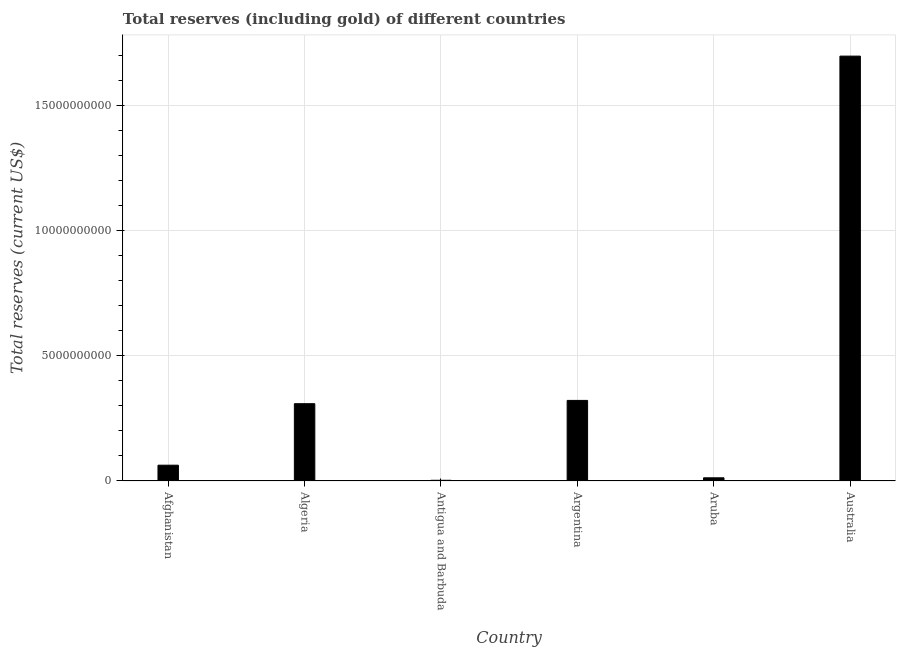Does the graph contain any zero values?
Your response must be concise. No. What is the title of the graph?
Provide a succinct answer. Total reserves (including gold) of different countries. What is the label or title of the Y-axis?
Make the answer very short. Total reserves (current US$). What is the total reserves (including gold) in Afghanistan?
Keep it short and to the point. 6.31e+08. Across all countries, what is the maximum total reserves (including gold)?
Give a very brief answer. 1.70e+1. Across all countries, what is the minimum total reserves (including gold)?
Provide a succinct answer. 2.81e+07. In which country was the total reserves (including gold) minimum?
Give a very brief answer. Antigua and Barbuda. What is the sum of the total reserves (including gold)?
Make the answer very short. 2.40e+1. What is the difference between the total reserves (including gold) in Afghanistan and Australia?
Your answer should be very brief. -1.63e+1. What is the average total reserves (including gold) per country?
Your response must be concise. 4.01e+09. What is the median total reserves (including gold)?
Offer a terse response. 1.86e+09. In how many countries, is the total reserves (including gold) greater than 2000000000 US$?
Provide a short and direct response. 3. What is the ratio of the total reserves (including gold) in Afghanistan to that in Australia?
Ensure brevity in your answer.  0.04. What is the difference between the highest and the second highest total reserves (including gold)?
Your response must be concise. 1.37e+1. Is the sum of the total reserves (including gold) in Antigua and Barbuda and Argentina greater than the maximum total reserves (including gold) across all countries?
Your answer should be very brief. No. What is the difference between the highest and the lowest total reserves (including gold)?
Keep it short and to the point. 1.69e+1. In how many countries, is the total reserves (including gold) greater than the average total reserves (including gold) taken over all countries?
Make the answer very short. 1. How many bars are there?
Ensure brevity in your answer.  6. What is the difference between two consecutive major ticks on the Y-axis?
Make the answer very short. 5.00e+09. What is the Total reserves (current US$) of Afghanistan?
Keep it short and to the point. 6.31e+08. What is the Total reserves (current US$) of Algeria?
Keep it short and to the point. 3.09e+09. What is the Total reserves (current US$) of Antigua and Barbuda?
Offer a terse response. 2.81e+07. What is the Total reserves (current US$) of Argentina?
Ensure brevity in your answer.  3.22e+09. What is the Total reserves (current US$) of Aruba?
Make the answer very short. 1.27e+08. What is the Total reserves (current US$) in Australia?
Provide a short and direct response. 1.70e+1. What is the difference between the Total reserves (current US$) in Afghanistan and Algeria?
Offer a very short reply. -2.46e+09. What is the difference between the Total reserves (current US$) in Afghanistan and Antigua and Barbuda?
Your answer should be compact. 6.03e+08. What is the difference between the Total reserves (current US$) in Afghanistan and Argentina?
Ensure brevity in your answer.  -2.59e+09. What is the difference between the Total reserves (current US$) in Afghanistan and Aruba?
Offer a very short reply. 5.03e+08. What is the difference between the Total reserves (current US$) in Afghanistan and Australia?
Ensure brevity in your answer.  -1.63e+1. What is the difference between the Total reserves (current US$) in Algeria and Antigua and Barbuda?
Give a very brief answer. 3.06e+09. What is the difference between the Total reserves (current US$) in Algeria and Argentina?
Your answer should be compact. -1.31e+08. What is the difference between the Total reserves (current US$) in Algeria and Aruba?
Your answer should be very brief. 2.96e+09. What is the difference between the Total reserves (current US$) in Algeria and Australia?
Ensure brevity in your answer.  -1.39e+1. What is the difference between the Total reserves (current US$) in Antigua and Barbuda and Argentina?
Offer a terse response. -3.19e+09. What is the difference between the Total reserves (current US$) in Antigua and Barbuda and Aruba?
Provide a succinct answer. -9.91e+07. What is the difference between the Total reserves (current US$) in Antigua and Barbuda and Australia?
Ensure brevity in your answer.  -1.69e+1. What is the difference between the Total reserves (current US$) in Argentina and Aruba?
Offer a very short reply. 3.09e+09. What is the difference between the Total reserves (current US$) in Argentina and Australia?
Keep it short and to the point. -1.37e+1. What is the difference between the Total reserves (current US$) in Aruba and Australia?
Provide a short and direct response. -1.68e+1. What is the ratio of the Total reserves (current US$) in Afghanistan to that in Algeria?
Your answer should be very brief. 0.2. What is the ratio of the Total reserves (current US$) in Afghanistan to that in Antigua and Barbuda?
Provide a succinct answer. 22.47. What is the ratio of the Total reserves (current US$) in Afghanistan to that in Argentina?
Provide a succinct answer. 0.2. What is the ratio of the Total reserves (current US$) in Afghanistan to that in Aruba?
Offer a very short reply. 4.96. What is the ratio of the Total reserves (current US$) in Afghanistan to that in Australia?
Make the answer very short. 0.04. What is the ratio of the Total reserves (current US$) in Algeria to that in Antigua and Barbuda?
Ensure brevity in your answer.  109.93. What is the ratio of the Total reserves (current US$) in Algeria to that in Aruba?
Your answer should be compact. 24.26. What is the ratio of the Total reserves (current US$) in Algeria to that in Australia?
Provide a succinct answer. 0.18. What is the ratio of the Total reserves (current US$) in Antigua and Barbuda to that in Argentina?
Your answer should be very brief. 0.01. What is the ratio of the Total reserves (current US$) in Antigua and Barbuda to that in Aruba?
Offer a terse response. 0.22. What is the ratio of the Total reserves (current US$) in Antigua and Barbuda to that in Australia?
Offer a terse response. 0. What is the ratio of the Total reserves (current US$) in Argentina to that in Aruba?
Your response must be concise. 25.3. What is the ratio of the Total reserves (current US$) in Argentina to that in Australia?
Offer a terse response. 0.19. What is the ratio of the Total reserves (current US$) in Aruba to that in Australia?
Ensure brevity in your answer.  0.01. 